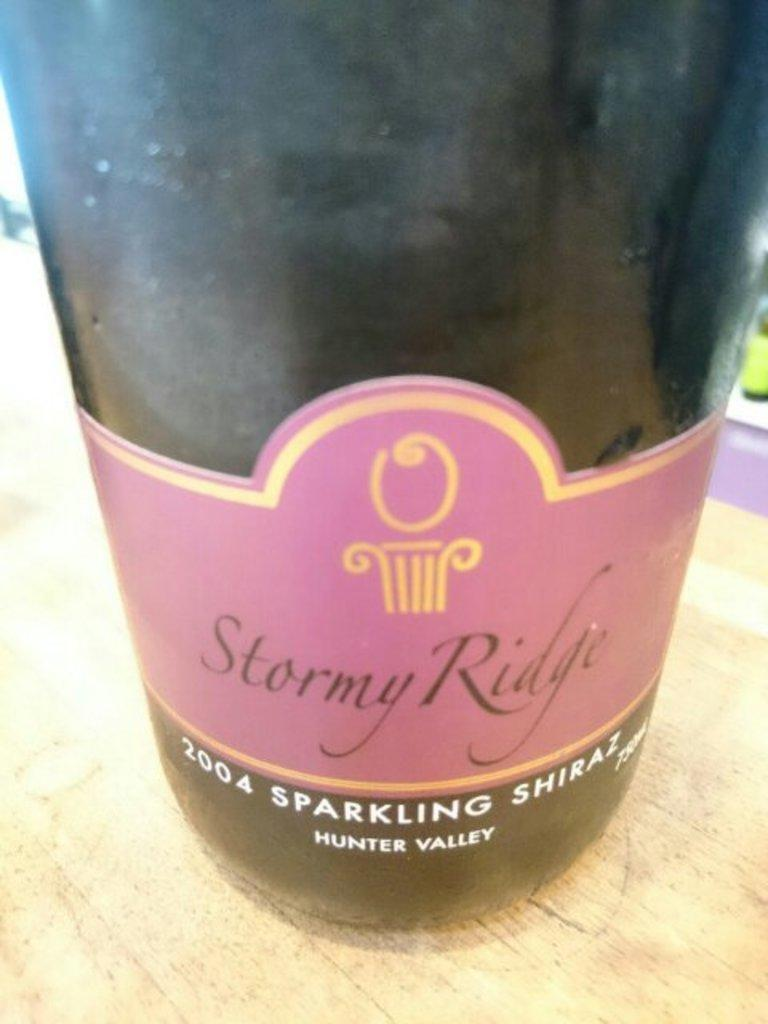<image>
Present a compact description of the photo's key features. Bottle of wine with a label that says "Stormy Ridge". 